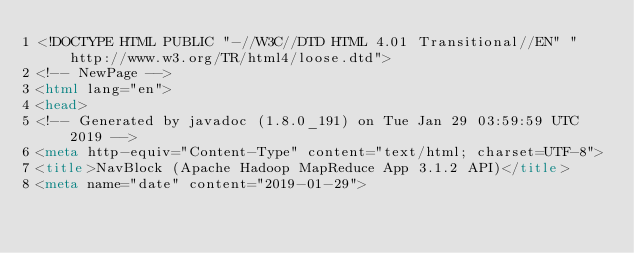Convert code to text. <code><loc_0><loc_0><loc_500><loc_500><_HTML_><!DOCTYPE HTML PUBLIC "-//W3C//DTD HTML 4.01 Transitional//EN" "http://www.w3.org/TR/html4/loose.dtd">
<!-- NewPage -->
<html lang="en">
<head>
<!-- Generated by javadoc (1.8.0_191) on Tue Jan 29 03:59:59 UTC 2019 -->
<meta http-equiv="Content-Type" content="text/html; charset=UTF-8">
<title>NavBlock (Apache Hadoop MapReduce App 3.1.2 API)</title>
<meta name="date" content="2019-01-29"></code> 